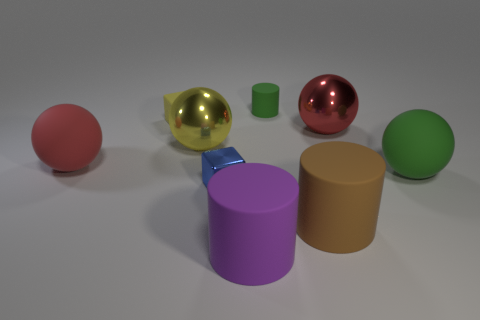What number of small green objects are the same material as the large brown object?
Provide a succinct answer. 1. There is a big green object; is its shape the same as the big red thing left of the red metal thing?
Ensure brevity in your answer.  Yes. There is a red ball on the right side of the big rubber thing that is left of the tiny shiny object; is there a object that is in front of it?
Offer a very short reply. Yes. There is a cylinder that is behind the large red metal thing; what is its size?
Your answer should be compact. Small. What material is the yellow block that is the same size as the blue metallic cube?
Your answer should be very brief. Rubber. Do the big red shiny thing and the yellow metal object have the same shape?
Make the answer very short. Yes. How many objects are either big cylinders or objects on the left side of the brown matte cylinder?
Offer a terse response. 7. There is a big object that is the same color as the small cylinder; what material is it?
Ensure brevity in your answer.  Rubber. There is a purple thing that is in front of the metal cube; does it have the same size as the blue cube?
Provide a short and direct response. No. What number of big matte objects are on the right side of the shiny sphere that is to the left of the small shiny object that is behind the large brown thing?
Provide a short and direct response. 3. 